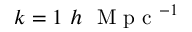Convert formula to latex. <formula><loc_0><loc_0><loc_500><loc_500>k = 1 \ h \ M p c ^ { - 1 }</formula> 